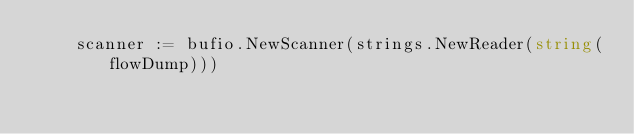Convert code to text. <code><loc_0><loc_0><loc_500><loc_500><_Go_>	scanner := bufio.NewScanner(strings.NewReader(string(flowDump)))</code> 